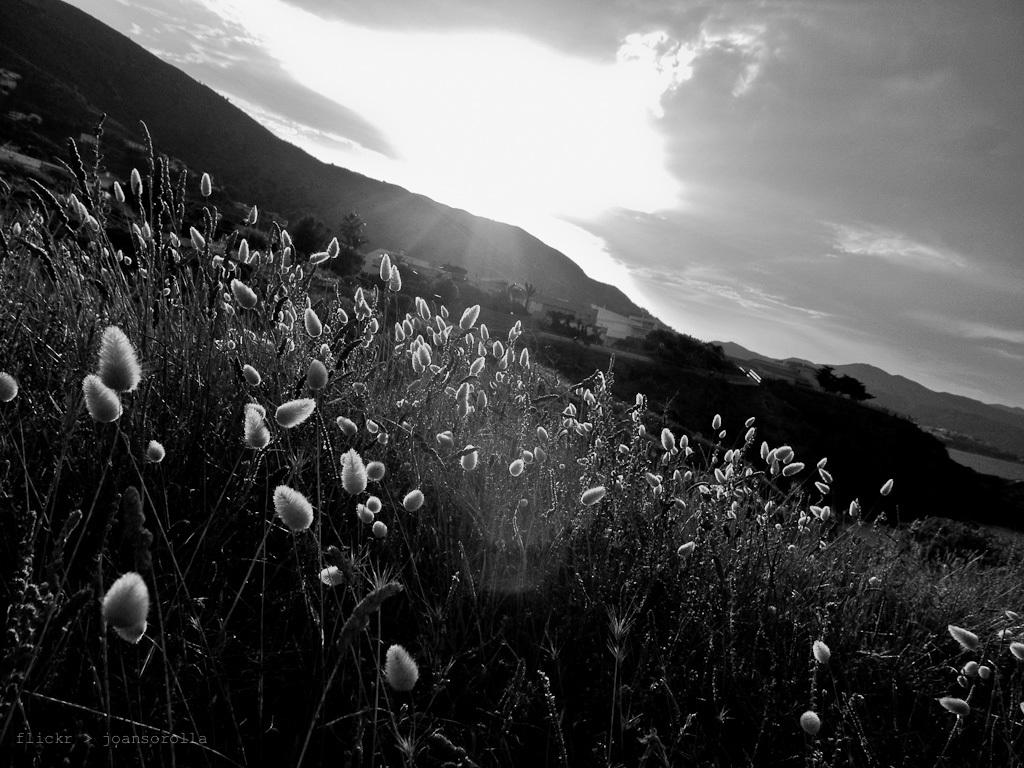What is the color scheme of the photograph? The photograph is black and white. What type of vegetation can be seen in the photograph? There are small flowers and grass visible in the photograph. What can be seen in the background of the photograph? Mountains, houses, and the sky are visible in the background. What is the condition of the sky in the photograph? Clouds are present in the sky. How many boats are docked at the harbor in the photograph? There is no harbor present in the photograph, so it is not possible to determine the number of boats docked there. 